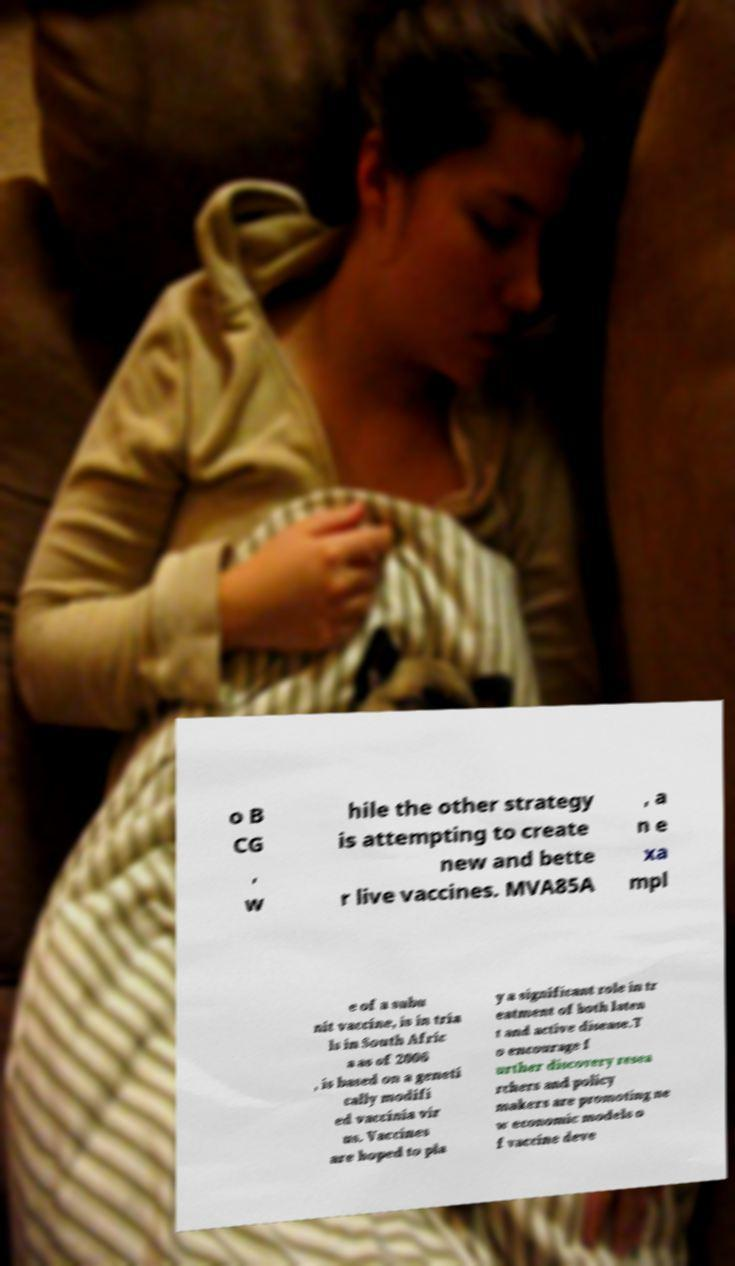Please identify and transcribe the text found in this image. o B CG , w hile the other strategy is attempting to create new and bette r live vaccines. MVA85A , a n e xa mpl e of a subu nit vaccine, is in tria ls in South Afric a as of 2006 , is based on a geneti cally modifi ed vaccinia vir us. Vaccines are hoped to pla y a significant role in tr eatment of both laten t and active disease.T o encourage f urther discovery resea rchers and policy makers are promoting ne w economic models o f vaccine deve 